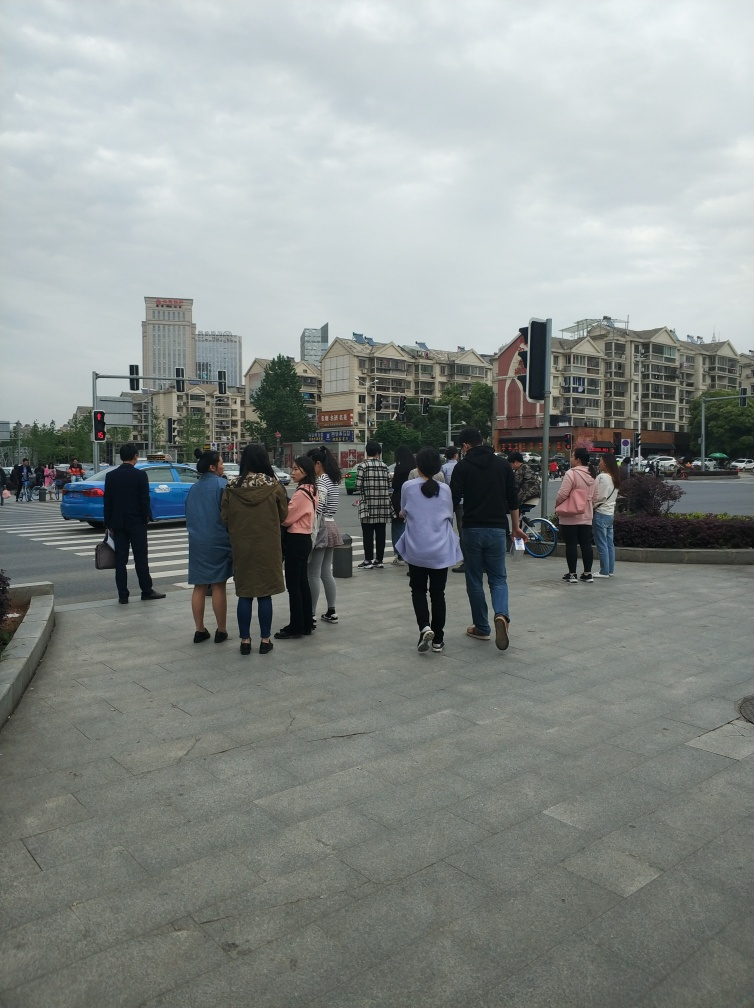Are there any visible distractions in this photo? The photo captures a relatively undistracted scene of people crossing the street, with no overt distractions present. However, minor distracting elements could be the various signages and the mix of architectural styles in the background, depending on the observer's perspective. 